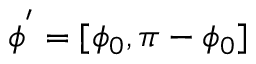<formula> <loc_0><loc_0><loc_500><loc_500>\phi ^ { ^ { \prime } } = [ \phi _ { 0 } , \pi - \phi _ { 0 } ]</formula> 